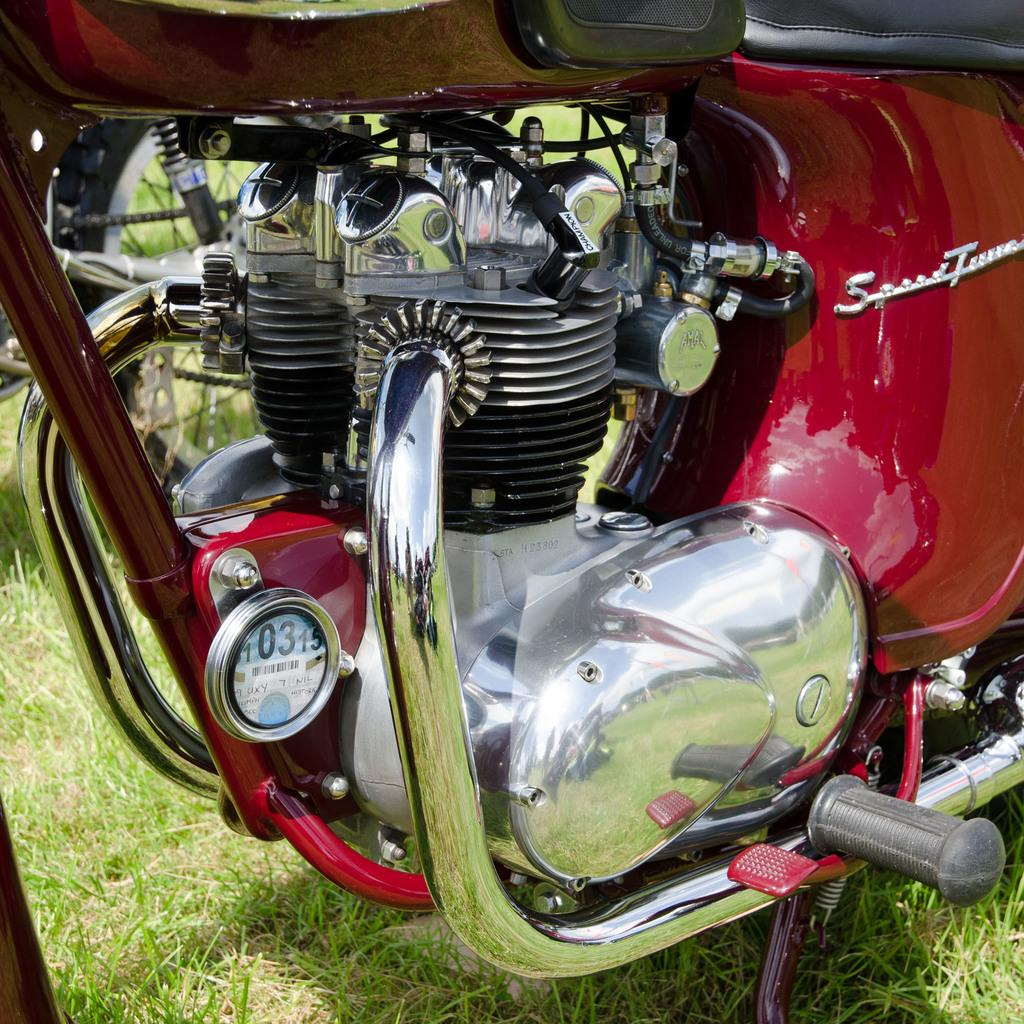What type of vehicle is partially shown in the image? There is a part of a motorcycle in the image. What type of terrain or environment is visible in the image? Grass is visible at the bottom of the image. What type of linen is being used to cover the motorcycle in the image? There is no linen present in the image, nor is the motorcycle covered by any material. 